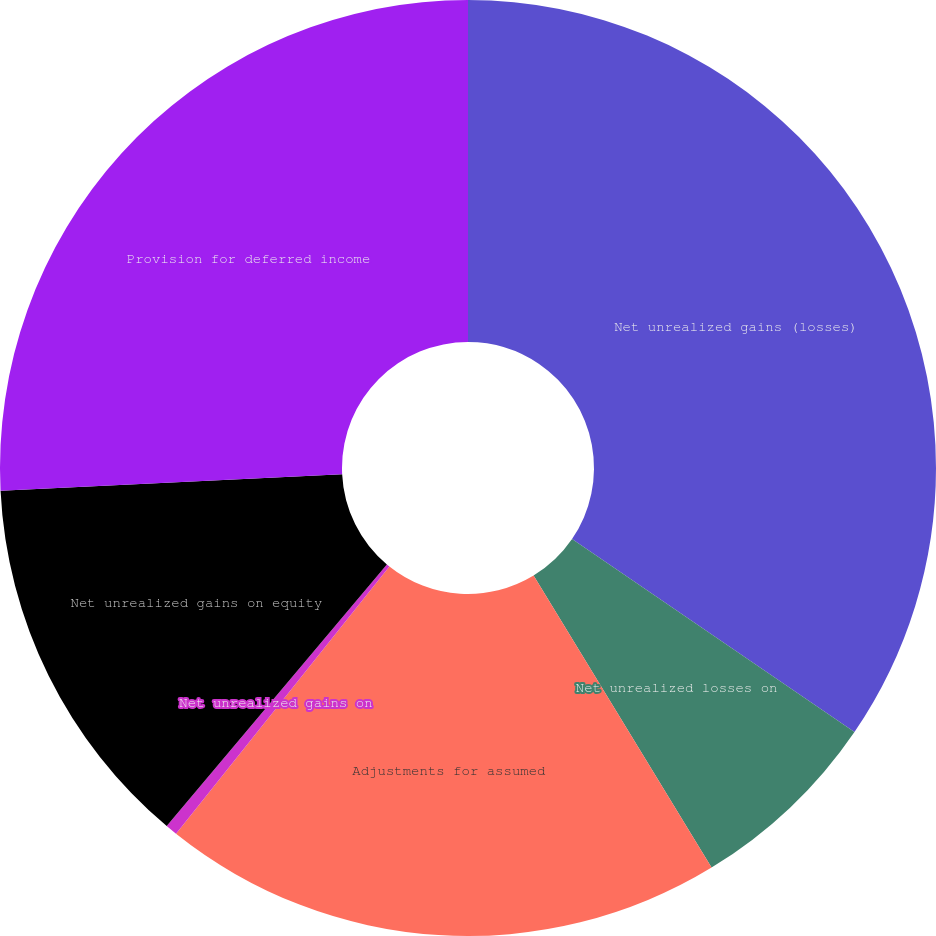<chart> <loc_0><loc_0><loc_500><loc_500><pie_chart><fcel>Net unrealized gains (losses)<fcel>Net unrealized losses on<fcel>Adjustments for assumed<fcel>Net unrealized gains on<fcel>Net unrealized gains on equity<fcel>Provision for deferred income<nl><fcel>34.53%<fcel>6.75%<fcel>19.43%<fcel>0.41%<fcel>13.09%<fcel>25.77%<nl></chart> 